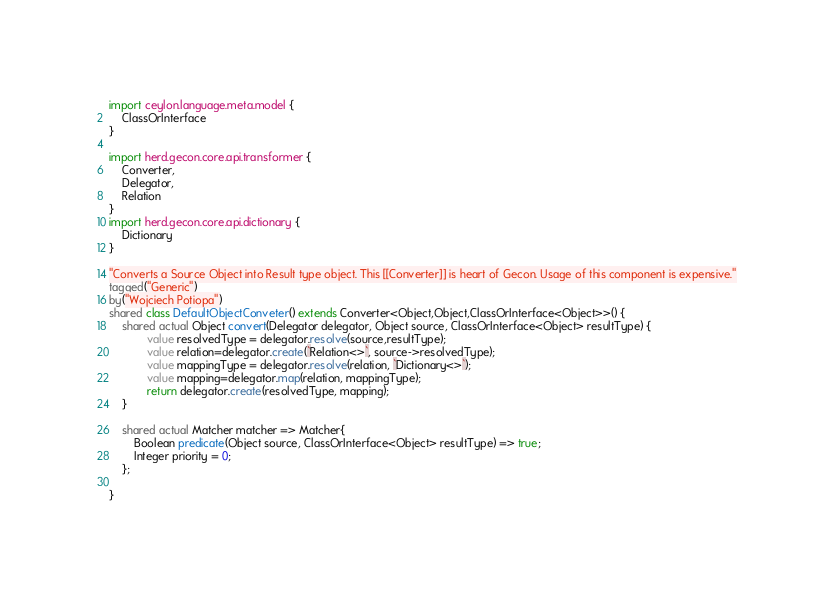<code> <loc_0><loc_0><loc_500><loc_500><_Ceylon_>

import ceylon.language.meta.model {
	ClassOrInterface
}

import herd.gecon.core.api.transformer {
	Converter,
	Delegator,
	Relation
}
import herd.gecon.core.api.dictionary {
	Dictionary
}

"Converts a Source Object into Result type object. This [[Converter]] is heart of Gecon. Usage of this component is expensive."
tagged("Generic")
by("Wojciech Potiopa")
shared class DefaultObjectConveter() extends Converter<Object,Object,ClassOrInterface<Object>>() {
	shared actual Object convert(Delegator delegator, Object source, ClassOrInterface<Object> resultType) {
			value resolvedType = delegator.resolve(source,resultType);
			value relation=delegator.create(`Relation<>`, source->resolvedType);
			value mappingType = delegator.resolve(relation, `Dictionary<>`);
			value mapping=delegator.map(relation, mappingType);
			return delegator.create(resolvedType, mapping);
	}
	
	shared actual Matcher matcher => Matcher{
		Boolean predicate(Object source, ClassOrInterface<Object> resultType) => true;
		Integer priority = 0;
	};
	
}		


</code> 